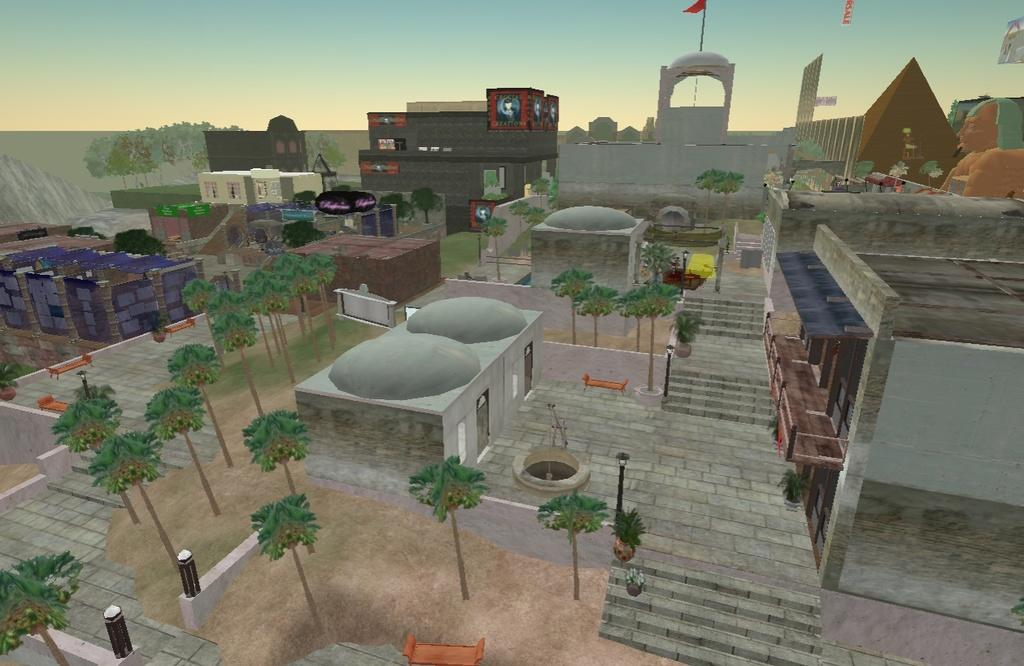What type of structures can be seen in the image? There are many buildings in the image. What type of vegetation is present in the image? There are trees in the image. What type of steel is used to construct the buildings in the image? The provided facts do not mention any specific type of steel used in the construction of the buildings. --- 